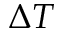Convert formula to latex. <formula><loc_0><loc_0><loc_500><loc_500>\Delta T</formula> 